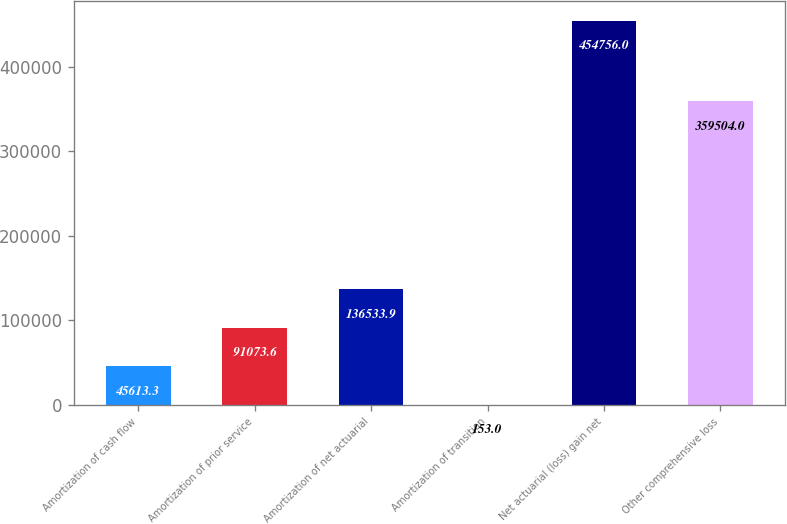Convert chart. <chart><loc_0><loc_0><loc_500><loc_500><bar_chart><fcel>Amortization of cash flow<fcel>Amortization of prior service<fcel>Amortization of net actuarial<fcel>Amortization of transition<fcel>Net actuarial (loss) gain net<fcel>Other comprehensive loss<nl><fcel>45613.3<fcel>91073.6<fcel>136534<fcel>153<fcel>454756<fcel>359504<nl></chart> 